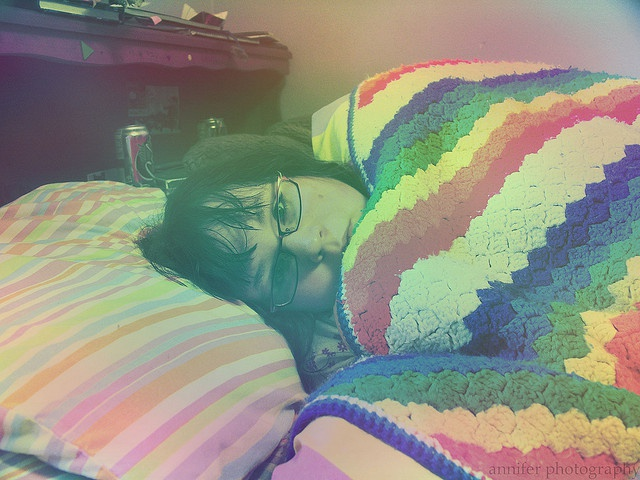Describe the objects in this image and their specific colors. I can see bed in blue, darkgray, tan, and lightgreen tones and people in blue, teal, and lightgreen tones in this image. 